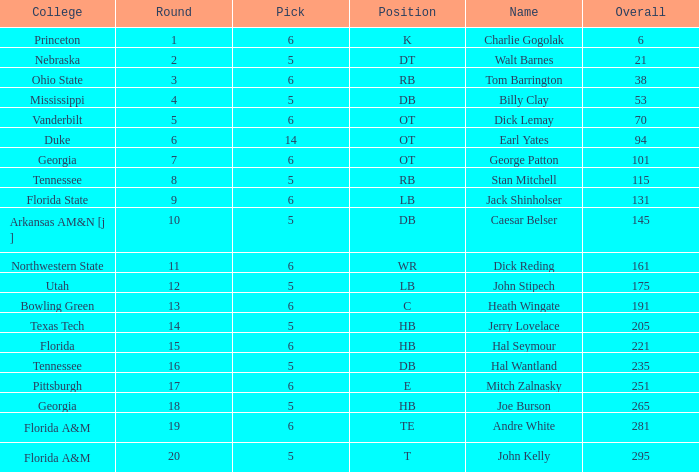What is the name in the case where overall is less than 175 and college is "georgia"? George Patton. 